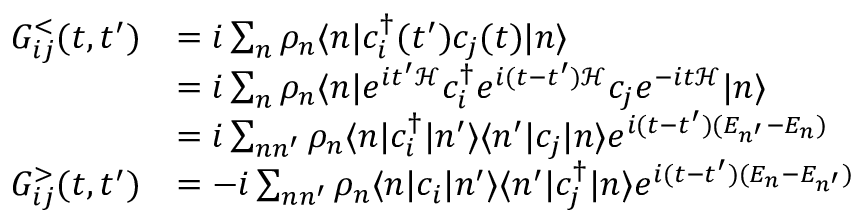<formula> <loc_0><loc_0><loc_500><loc_500>\begin{array} { r l } { G _ { i j } ^ { < } ( t , t ^ { \prime } ) } & { = i \sum _ { n } \rho _ { n } \langle n | c _ { i } ^ { \dagger } ( t ^ { \prime } ) c _ { j } ( t ) | n \rangle } \\ & { = i \sum _ { n } \rho _ { n } \langle n | e ^ { i t ^ { \prime } \mathcal { H } } c _ { i } ^ { \dagger } e ^ { i ( t - t ^ { \prime } ) \mathcal { H } } c _ { j } e ^ { - i t \mathcal { H } } | n \rangle } \\ & { = i \sum _ { n n ^ { \prime } } \rho _ { n } \langle n | c _ { i } ^ { \dagger } | n ^ { \prime } \rangle \langle n ^ { \prime } | c _ { j } | n \rangle e ^ { i ( t - t ^ { \prime } ) ( E _ { n ^ { \prime } } - E _ { n } ) } } \\ { G _ { i j } ^ { > } ( t , t ^ { \prime } ) } & { = - i \sum _ { n n ^ { \prime } } \rho _ { n } \langle n | c _ { i } | n ^ { \prime } \rangle \langle n ^ { \prime } | c _ { j } ^ { \dagger } | n \rangle e ^ { i ( t - t ^ { \prime } ) ( E _ { n } - E _ { n ^ { \prime } } ) } } \end{array}</formula> 